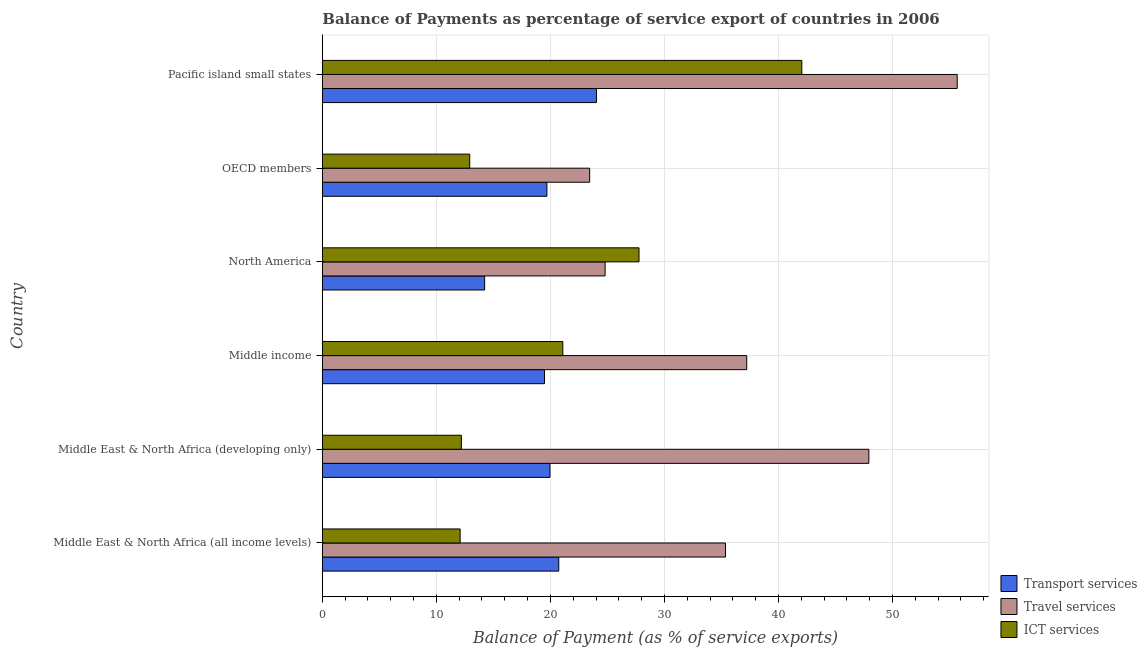How many different coloured bars are there?
Give a very brief answer. 3. How many groups of bars are there?
Offer a terse response. 6. Are the number of bars per tick equal to the number of legend labels?
Your answer should be very brief. Yes. Are the number of bars on each tick of the Y-axis equal?
Provide a short and direct response. Yes. What is the label of the 5th group of bars from the top?
Keep it short and to the point. Middle East & North Africa (developing only). In how many cases, is the number of bars for a given country not equal to the number of legend labels?
Your answer should be very brief. 0. What is the balance of payment of ict services in OECD members?
Your answer should be compact. 12.93. Across all countries, what is the maximum balance of payment of transport services?
Offer a very short reply. 24.04. Across all countries, what is the minimum balance of payment of travel services?
Your answer should be very brief. 23.44. In which country was the balance of payment of transport services maximum?
Offer a very short reply. Pacific island small states. In which country was the balance of payment of transport services minimum?
Your answer should be compact. North America. What is the total balance of payment of ict services in the graph?
Make the answer very short. 128.11. What is the difference between the balance of payment of travel services in Middle East & North Africa (developing only) and that in OECD members?
Your response must be concise. 24.48. What is the difference between the balance of payment of ict services in OECD members and the balance of payment of travel services in North America?
Provide a succinct answer. -11.87. What is the average balance of payment of transport services per country?
Ensure brevity in your answer.  19.69. What is the difference between the balance of payment of transport services and balance of payment of travel services in Middle East & North Africa (all income levels)?
Ensure brevity in your answer.  -14.62. What is the ratio of the balance of payment of transport services in Middle East & North Africa (all income levels) to that in Middle East & North Africa (developing only)?
Ensure brevity in your answer.  1.04. What is the difference between the highest and the second highest balance of payment of transport services?
Provide a short and direct response. 3.31. What is the difference between the highest and the lowest balance of payment of travel services?
Keep it short and to the point. 32.23. In how many countries, is the balance of payment of ict services greater than the average balance of payment of ict services taken over all countries?
Your response must be concise. 2. What does the 2nd bar from the top in Middle East & North Africa (all income levels) represents?
Keep it short and to the point. Travel services. What does the 1st bar from the bottom in Middle East & North Africa (all income levels) represents?
Provide a succinct answer. Transport services. Is it the case that in every country, the sum of the balance of payment of transport services and balance of payment of travel services is greater than the balance of payment of ict services?
Provide a short and direct response. Yes. How many bars are there?
Give a very brief answer. 18. Are all the bars in the graph horizontal?
Provide a succinct answer. Yes. How many countries are there in the graph?
Your answer should be very brief. 6. Are the values on the major ticks of X-axis written in scientific E-notation?
Make the answer very short. No. Does the graph contain any zero values?
Your answer should be very brief. No. Does the graph contain grids?
Ensure brevity in your answer.  Yes. What is the title of the graph?
Make the answer very short. Balance of Payments as percentage of service export of countries in 2006. Does "Renewable sources" appear as one of the legend labels in the graph?
Ensure brevity in your answer.  No. What is the label or title of the X-axis?
Your response must be concise. Balance of Payment (as % of service exports). What is the label or title of the Y-axis?
Ensure brevity in your answer.  Country. What is the Balance of Payment (as % of service exports) of Transport services in Middle East & North Africa (all income levels)?
Your answer should be compact. 20.73. What is the Balance of Payment (as % of service exports) of Travel services in Middle East & North Africa (all income levels)?
Your answer should be compact. 35.36. What is the Balance of Payment (as % of service exports) in ICT services in Middle East & North Africa (all income levels)?
Your answer should be very brief. 12.08. What is the Balance of Payment (as % of service exports) of Transport services in Middle East & North Africa (developing only)?
Offer a terse response. 19.96. What is the Balance of Payment (as % of service exports) in Travel services in Middle East & North Africa (developing only)?
Provide a succinct answer. 47.93. What is the Balance of Payment (as % of service exports) of ICT services in Middle East & North Africa (developing only)?
Keep it short and to the point. 12.19. What is the Balance of Payment (as % of service exports) of Transport services in Middle income?
Your answer should be compact. 19.48. What is the Balance of Payment (as % of service exports) of Travel services in Middle income?
Offer a very short reply. 37.21. What is the Balance of Payment (as % of service exports) of ICT services in Middle income?
Give a very brief answer. 21.09. What is the Balance of Payment (as % of service exports) of Transport services in North America?
Your answer should be very brief. 14.23. What is the Balance of Payment (as % of service exports) of Travel services in North America?
Provide a succinct answer. 24.8. What is the Balance of Payment (as % of service exports) in ICT services in North America?
Offer a terse response. 27.77. What is the Balance of Payment (as % of service exports) of Transport services in OECD members?
Offer a very short reply. 19.69. What is the Balance of Payment (as % of service exports) of Travel services in OECD members?
Keep it short and to the point. 23.44. What is the Balance of Payment (as % of service exports) of ICT services in OECD members?
Provide a succinct answer. 12.93. What is the Balance of Payment (as % of service exports) in Transport services in Pacific island small states?
Ensure brevity in your answer.  24.04. What is the Balance of Payment (as % of service exports) in Travel services in Pacific island small states?
Keep it short and to the point. 55.67. What is the Balance of Payment (as % of service exports) in ICT services in Pacific island small states?
Provide a succinct answer. 42.04. Across all countries, what is the maximum Balance of Payment (as % of service exports) in Transport services?
Keep it short and to the point. 24.04. Across all countries, what is the maximum Balance of Payment (as % of service exports) in Travel services?
Give a very brief answer. 55.67. Across all countries, what is the maximum Balance of Payment (as % of service exports) of ICT services?
Ensure brevity in your answer.  42.04. Across all countries, what is the minimum Balance of Payment (as % of service exports) of Transport services?
Your answer should be compact. 14.23. Across all countries, what is the minimum Balance of Payment (as % of service exports) in Travel services?
Make the answer very short. 23.44. Across all countries, what is the minimum Balance of Payment (as % of service exports) in ICT services?
Offer a very short reply. 12.08. What is the total Balance of Payment (as % of service exports) of Transport services in the graph?
Keep it short and to the point. 118.14. What is the total Balance of Payment (as % of service exports) of Travel services in the graph?
Offer a very short reply. 224.41. What is the total Balance of Payment (as % of service exports) of ICT services in the graph?
Offer a very short reply. 128.11. What is the difference between the Balance of Payment (as % of service exports) of Transport services in Middle East & North Africa (all income levels) and that in Middle East & North Africa (developing only)?
Provide a succinct answer. 0.77. What is the difference between the Balance of Payment (as % of service exports) of Travel services in Middle East & North Africa (all income levels) and that in Middle East & North Africa (developing only)?
Your answer should be very brief. -12.57. What is the difference between the Balance of Payment (as % of service exports) in ICT services in Middle East & North Africa (all income levels) and that in Middle East & North Africa (developing only)?
Provide a succinct answer. -0.11. What is the difference between the Balance of Payment (as % of service exports) in Transport services in Middle East & North Africa (all income levels) and that in Middle income?
Provide a succinct answer. 1.25. What is the difference between the Balance of Payment (as % of service exports) of Travel services in Middle East & North Africa (all income levels) and that in Middle income?
Keep it short and to the point. -1.86. What is the difference between the Balance of Payment (as % of service exports) of ICT services in Middle East & North Africa (all income levels) and that in Middle income?
Keep it short and to the point. -9. What is the difference between the Balance of Payment (as % of service exports) of Transport services in Middle East & North Africa (all income levels) and that in North America?
Provide a short and direct response. 6.5. What is the difference between the Balance of Payment (as % of service exports) of Travel services in Middle East & North Africa (all income levels) and that in North America?
Your response must be concise. 10.56. What is the difference between the Balance of Payment (as % of service exports) in ICT services in Middle East & North Africa (all income levels) and that in North America?
Your answer should be very brief. -15.69. What is the difference between the Balance of Payment (as % of service exports) of Transport services in Middle East & North Africa (all income levels) and that in OECD members?
Provide a short and direct response. 1.04. What is the difference between the Balance of Payment (as % of service exports) of Travel services in Middle East & North Africa (all income levels) and that in OECD members?
Keep it short and to the point. 11.92. What is the difference between the Balance of Payment (as % of service exports) in ICT services in Middle East & North Africa (all income levels) and that in OECD members?
Your response must be concise. -0.84. What is the difference between the Balance of Payment (as % of service exports) of Transport services in Middle East & North Africa (all income levels) and that in Pacific island small states?
Make the answer very short. -3.3. What is the difference between the Balance of Payment (as % of service exports) in Travel services in Middle East & North Africa (all income levels) and that in Pacific island small states?
Provide a short and direct response. -20.31. What is the difference between the Balance of Payment (as % of service exports) of ICT services in Middle East & North Africa (all income levels) and that in Pacific island small states?
Your answer should be very brief. -29.96. What is the difference between the Balance of Payment (as % of service exports) of Transport services in Middle East & North Africa (developing only) and that in Middle income?
Your answer should be compact. 0.48. What is the difference between the Balance of Payment (as % of service exports) of Travel services in Middle East & North Africa (developing only) and that in Middle income?
Your answer should be compact. 10.71. What is the difference between the Balance of Payment (as % of service exports) in ICT services in Middle East & North Africa (developing only) and that in Middle income?
Provide a succinct answer. -8.9. What is the difference between the Balance of Payment (as % of service exports) of Transport services in Middle East & North Africa (developing only) and that in North America?
Provide a short and direct response. 5.73. What is the difference between the Balance of Payment (as % of service exports) of Travel services in Middle East & North Africa (developing only) and that in North America?
Provide a succinct answer. 23.13. What is the difference between the Balance of Payment (as % of service exports) of ICT services in Middle East & North Africa (developing only) and that in North America?
Ensure brevity in your answer.  -15.58. What is the difference between the Balance of Payment (as % of service exports) of Transport services in Middle East & North Africa (developing only) and that in OECD members?
Provide a short and direct response. 0.27. What is the difference between the Balance of Payment (as % of service exports) in Travel services in Middle East & North Africa (developing only) and that in OECD members?
Offer a terse response. 24.48. What is the difference between the Balance of Payment (as % of service exports) of ICT services in Middle East & North Africa (developing only) and that in OECD members?
Offer a very short reply. -0.73. What is the difference between the Balance of Payment (as % of service exports) in Transport services in Middle East & North Africa (developing only) and that in Pacific island small states?
Provide a short and direct response. -4.08. What is the difference between the Balance of Payment (as % of service exports) in Travel services in Middle East & North Africa (developing only) and that in Pacific island small states?
Your answer should be very brief. -7.75. What is the difference between the Balance of Payment (as % of service exports) in ICT services in Middle East & North Africa (developing only) and that in Pacific island small states?
Keep it short and to the point. -29.85. What is the difference between the Balance of Payment (as % of service exports) of Transport services in Middle income and that in North America?
Your answer should be very brief. 5.25. What is the difference between the Balance of Payment (as % of service exports) of Travel services in Middle income and that in North America?
Provide a succinct answer. 12.42. What is the difference between the Balance of Payment (as % of service exports) in ICT services in Middle income and that in North America?
Your answer should be very brief. -6.68. What is the difference between the Balance of Payment (as % of service exports) in Transport services in Middle income and that in OECD members?
Provide a short and direct response. -0.21. What is the difference between the Balance of Payment (as % of service exports) in Travel services in Middle income and that in OECD members?
Offer a terse response. 13.77. What is the difference between the Balance of Payment (as % of service exports) in ICT services in Middle income and that in OECD members?
Offer a terse response. 8.16. What is the difference between the Balance of Payment (as % of service exports) of Transport services in Middle income and that in Pacific island small states?
Offer a terse response. -4.56. What is the difference between the Balance of Payment (as % of service exports) of Travel services in Middle income and that in Pacific island small states?
Offer a very short reply. -18.46. What is the difference between the Balance of Payment (as % of service exports) of ICT services in Middle income and that in Pacific island small states?
Your response must be concise. -20.96. What is the difference between the Balance of Payment (as % of service exports) in Transport services in North America and that in OECD members?
Your answer should be compact. -5.46. What is the difference between the Balance of Payment (as % of service exports) of Travel services in North America and that in OECD members?
Keep it short and to the point. 1.36. What is the difference between the Balance of Payment (as % of service exports) in ICT services in North America and that in OECD members?
Offer a very short reply. 14.84. What is the difference between the Balance of Payment (as % of service exports) in Transport services in North America and that in Pacific island small states?
Your answer should be compact. -9.8. What is the difference between the Balance of Payment (as % of service exports) of Travel services in North America and that in Pacific island small states?
Your response must be concise. -30.87. What is the difference between the Balance of Payment (as % of service exports) in ICT services in North America and that in Pacific island small states?
Provide a short and direct response. -14.27. What is the difference between the Balance of Payment (as % of service exports) in Transport services in OECD members and that in Pacific island small states?
Provide a short and direct response. -4.34. What is the difference between the Balance of Payment (as % of service exports) in Travel services in OECD members and that in Pacific island small states?
Your answer should be very brief. -32.23. What is the difference between the Balance of Payment (as % of service exports) of ICT services in OECD members and that in Pacific island small states?
Offer a terse response. -29.12. What is the difference between the Balance of Payment (as % of service exports) of Transport services in Middle East & North Africa (all income levels) and the Balance of Payment (as % of service exports) of Travel services in Middle East & North Africa (developing only)?
Provide a succinct answer. -27.19. What is the difference between the Balance of Payment (as % of service exports) of Transport services in Middle East & North Africa (all income levels) and the Balance of Payment (as % of service exports) of ICT services in Middle East & North Africa (developing only)?
Your response must be concise. 8.54. What is the difference between the Balance of Payment (as % of service exports) in Travel services in Middle East & North Africa (all income levels) and the Balance of Payment (as % of service exports) in ICT services in Middle East & North Africa (developing only)?
Ensure brevity in your answer.  23.16. What is the difference between the Balance of Payment (as % of service exports) in Transport services in Middle East & North Africa (all income levels) and the Balance of Payment (as % of service exports) in Travel services in Middle income?
Your answer should be compact. -16.48. What is the difference between the Balance of Payment (as % of service exports) in Transport services in Middle East & North Africa (all income levels) and the Balance of Payment (as % of service exports) in ICT services in Middle income?
Make the answer very short. -0.36. What is the difference between the Balance of Payment (as % of service exports) of Travel services in Middle East & North Africa (all income levels) and the Balance of Payment (as % of service exports) of ICT services in Middle income?
Your answer should be compact. 14.27. What is the difference between the Balance of Payment (as % of service exports) of Transport services in Middle East & North Africa (all income levels) and the Balance of Payment (as % of service exports) of Travel services in North America?
Provide a succinct answer. -4.06. What is the difference between the Balance of Payment (as % of service exports) in Transport services in Middle East & North Africa (all income levels) and the Balance of Payment (as % of service exports) in ICT services in North America?
Offer a very short reply. -7.04. What is the difference between the Balance of Payment (as % of service exports) of Travel services in Middle East & North Africa (all income levels) and the Balance of Payment (as % of service exports) of ICT services in North America?
Make the answer very short. 7.59. What is the difference between the Balance of Payment (as % of service exports) in Transport services in Middle East & North Africa (all income levels) and the Balance of Payment (as % of service exports) in Travel services in OECD members?
Your response must be concise. -2.71. What is the difference between the Balance of Payment (as % of service exports) of Transport services in Middle East & North Africa (all income levels) and the Balance of Payment (as % of service exports) of ICT services in OECD members?
Give a very brief answer. 7.81. What is the difference between the Balance of Payment (as % of service exports) in Travel services in Middle East & North Africa (all income levels) and the Balance of Payment (as % of service exports) in ICT services in OECD members?
Provide a succinct answer. 22.43. What is the difference between the Balance of Payment (as % of service exports) of Transport services in Middle East & North Africa (all income levels) and the Balance of Payment (as % of service exports) of Travel services in Pacific island small states?
Give a very brief answer. -34.94. What is the difference between the Balance of Payment (as % of service exports) in Transport services in Middle East & North Africa (all income levels) and the Balance of Payment (as % of service exports) in ICT services in Pacific island small states?
Ensure brevity in your answer.  -21.31. What is the difference between the Balance of Payment (as % of service exports) of Travel services in Middle East & North Africa (all income levels) and the Balance of Payment (as % of service exports) of ICT services in Pacific island small states?
Your answer should be compact. -6.69. What is the difference between the Balance of Payment (as % of service exports) of Transport services in Middle East & North Africa (developing only) and the Balance of Payment (as % of service exports) of Travel services in Middle income?
Ensure brevity in your answer.  -17.25. What is the difference between the Balance of Payment (as % of service exports) in Transport services in Middle East & North Africa (developing only) and the Balance of Payment (as % of service exports) in ICT services in Middle income?
Offer a terse response. -1.13. What is the difference between the Balance of Payment (as % of service exports) of Travel services in Middle East & North Africa (developing only) and the Balance of Payment (as % of service exports) of ICT services in Middle income?
Keep it short and to the point. 26.84. What is the difference between the Balance of Payment (as % of service exports) in Transport services in Middle East & North Africa (developing only) and the Balance of Payment (as % of service exports) in Travel services in North America?
Make the answer very short. -4.83. What is the difference between the Balance of Payment (as % of service exports) in Transport services in Middle East & North Africa (developing only) and the Balance of Payment (as % of service exports) in ICT services in North America?
Give a very brief answer. -7.81. What is the difference between the Balance of Payment (as % of service exports) of Travel services in Middle East & North Africa (developing only) and the Balance of Payment (as % of service exports) of ICT services in North America?
Keep it short and to the point. 20.16. What is the difference between the Balance of Payment (as % of service exports) of Transport services in Middle East & North Africa (developing only) and the Balance of Payment (as % of service exports) of Travel services in OECD members?
Provide a short and direct response. -3.48. What is the difference between the Balance of Payment (as % of service exports) of Transport services in Middle East & North Africa (developing only) and the Balance of Payment (as % of service exports) of ICT services in OECD members?
Ensure brevity in your answer.  7.04. What is the difference between the Balance of Payment (as % of service exports) of Travel services in Middle East & North Africa (developing only) and the Balance of Payment (as % of service exports) of ICT services in OECD members?
Your answer should be very brief. 35. What is the difference between the Balance of Payment (as % of service exports) of Transport services in Middle East & North Africa (developing only) and the Balance of Payment (as % of service exports) of Travel services in Pacific island small states?
Provide a succinct answer. -35.71. What is the difference between the Balance of Payment (as % of service exports) of Transport services in Middle East & North Africa (developing only) and the Balance of Payment (as % of service exports) of ICT services in Pacific island small states?
Ensure brevity in your answer.  -22.08. What is the difference between the Balance of Payment (as % of service exports) in Travel services in Middle East & North Africa (developing only) and the Balance of Payment (as % of service exports) in ICT services in Pacific island small states?
Offer a very short reply. 5.88. What is the difference between the Balance of Payment (as % of service exports) of Transport services in Middle income and the Balance of Payment (as % of service exports) of Travel services in North America?
Keep it short and to the point. -5.32. What is the difference between the Balance of Payment (as % of service exports) in Transport services in Middle income and the Balance of Payment (as % of service exports) in ICT services in North America?
Offer a terse response. -8.29. What is the difference between the Balance of Payment (as % of service exports) in Travel services in Middle income and the Balance of Payment (as % of service exports) in ICT services in North America?
Offer a terse response. 9.44. What is the difference between the Balance of Payment (as % of service exports) in Transport services in Middle income and the Balance of Payment (as % of service exports) in Travel services in OECD members?
Offer a terse response. -3.96. What is the difference between the Balance of Payment (as % of service exports) in Transport services in Middle income and the Balance of Payment (as % of service exports) in ICT services in OECD members?
Make the answer very short. 6.56. What is the difference between the Balance of Payment (as % of service exports) in Travel services in Middle income and the Balance of Payment (as % of service exports) in ICT services in OECD members?
Ensure brevity in your answer.  24.29. What is the difference between the Balance of Payment (as % of service exports) of Transport services in Middle income and the Balance of Payment (as % of service exports) of Travel services in Pacific island small states?
Provide a succinct answer. -36.19. What is the difference between the Balance of Payment (as % of service exports) in Transport services in Middle income and the Balance of Payment (as % of service exports) in ICT services in Pacific island small states?
Offer a very short reply. -22.56. What is the difference between the Balance of Payment (as % of service exports) in Travel services in Middle income and the Balance of Payment (as % of service exports) in ICT services in Pacific island small states?
Give a very brief answer. -4.83. What is the difference between the Balance of Payment (as % of service exports) of Transport services in North America and the Balance of Payment (as % of service exports) of Travel services in OECD members?
Offer a terse response. -9.21. What is the difference between the Balance of Payment (as % of service exports) of Transport services in North America and the Balance of Payment (as % of service exports) of ICT services in OECD members?
Provide a short and direct response. 1.31. What is the difference between the Balance of Payment (as % of service exports) of Travel services in North America and the Balance of Payment (as % of service exports) of ICT services in OECD members?
Your answer should be very brief. 11.87. What is the difference between the Balance of Payment (as % of service exports) of Transport services in North America and the Balance of Payment (as % of service exports) of Travel services in Pacific island small states?
Your answer should be compact. -41.44. What is the difference between the Balance of Payment (as % of service exports) in Transport services in North America and the Balance of Payment (as % of service exports) in ICT services in Pacific island small states?
Your answer should be compact. -27.81. What is the difference between the Balance of Payment (as % of service exports) in Travel services in North America and the Balance of Payment (as % of service exports) in ICT services in Pacific island small states?
Provide a succinct answer. -17.25. What is the difference between the Balance of Payment (as % of service exports) of Transport services in OECD members and the Balance of Payment (as % of service exports) of Travel services in Pacific island small states?
Offer a very short reply. -35.98. What is the difference between the Balance of Payment (as % of service exports) in Transport services in OECD members and the Balance of Payment (as % of service exports) in ICT services in Pacific island small states?
Provide a succinct answer. -22.35. What is the difference between the Balance of Payment (as % of service exports) in Travel services in OECD members and the Balance of Payment (as % of service exports) in ICT services in Pacific island small states?
Provide a short and direct response. -18.6. What is the average Balance of Payment (as % of service exports) of Transport services per country?
Give a very brief answer. 19.69. What is the average Balance of Payment (as % of service exports) in Travel services per country?
Offer a very short reply. 37.4. What is the average Balance of Payment (as % of service exports) in ICT services per country?
Provide a succinct answer. 21.35. What is the difference between the Balance of Payment (as % of service exports) of Transport services and Balance of Payment (as % of service exports) of Travel services in Middle East & North Africa (all income levels)?
Your answer should be compact. -14.62. What is the difference between the Balance of Payment (as % of service exports) in Transport services and Balance of Payment (as % of service exports) in ICT services in Middle East & North Africa (all income levels)?
Make the answer very short. 8.65. What is the difference between the Balance of Payment (as % of service exports) in Travel services and Balance of Payment (as % of service exports) in ICT services in Middle East & North Africa (all income levels)?
Offer a terse response. 23.27. What is the difference between the Balance of Payment (as % of service exports) of Transport services and Balance of Payment (as % of service exports) of Travel services in Middle East & North Africa (developing only)?
Ensure brevity in your answer.  -27.96. What is the difference between the Balance of Payment (as % of service exports) in Transport services and Balance of Payment (as % of service exports) in ICT services in Middle East & North Africa (developing only)?
Keep it short and to the point. 7.77. What is the difference between the Balance of Payment (as % of service exports) of Travel services and Balance of Payment (as % of service exports) of ICT services in Middle East & North Africa (developing only)?
Offer a very short reply. 35.73. What is the difference between the Balance of Payment (as % of service exports) of Transport services and Balance of Payment (as % of service exports) of Travel services in Middle income?
Keep it short and to the point. -17.73. What is the difference between the Balance of Payment (as % of service exports) of Transport services and Balance of Payment (as % of service exports) of ICT services in Middle income?
Give a very brief answer. -1.61. What is the difference between the Balance of Payment (as % of service exports) in Travel services and Balance of Payment (as % of service exports) in ICT services in Middle income?
Your answer should be very brief. 16.13. What is the difference between the Balance of Payment (as % of service exports) in Transport services and Balance of Payment (as % of service exports) in Travel services in North America?
Your answer should be compact. -10.56. What is the difference between the Balance of Payment (as % of service exports) of Transport services and Balance of Payment (as % of service exports) of ICT services in North America?
Your response must be concise. -13.54. What is the difference between the Balance of Payment (as % of service exports) in Travel services and Balance of Payment (as % of service exports) in ICT services in North America?
Your answer should be very brief. -2.97. What is the difference between the Balance of Payment (as % of service exports) in Transport services and Balance of Payment (as % of service exports) in Travel services in OECD members?
Offer a very short reply. -3.75. What is the difference between the Balance of Payment (as % of service exports) in Transport services and Balance of Payment (as % of service exports) in ICT services in OECD members?
Your answer should be compact. 6.77. What is the difference between the Balance of Payment (as % of service exports) in Travel services and Balance of Payment (as % of service exports) in ICT services in OECD members?
Make the answer very short. 10.51. What is the difference between the Balance of Payment (as % of service exports) in Transport services and Balance of Payment (as % of service exports) in Travel services in Pacific island small states?
Your answer should be very brief. -31.63. What is the difference between the Balance of Payment (as % of service exports) in Transport services and Balance of Payment (as % of service exports) in ICT services in Pacific island small states?
Your answer should be very brief. -18.01. What is the difference between the Balance of Payment (as % of service exports) in Travel services and Balance of Payment (as % of service exports) in ICT services in Pacific island small states?
Your answer should be very brief. 13.63. What is the ratio of the Balance of Payment (as % of service exports) in Transport services in Middle East & North Africa (all income levels) to that in Middle East & North Africa (developing only)?
Keep it short and to the point. 1.04. What is the ratio of the Balance of Payment (as % of service exports) of Travel services in Middle East & North Africa (all income levels) to that in Middle East & North Africa (developing only)?
Your answer should be very brief. 0.74. What is the ratio of the Balance of Payment (as % of service exports) in Transport services in Middle East & North Africa (all income levels) to that in Middle income?
Ensure brevity in your answer.  1.06. What is the ratio of the Balance of Payment (as % of service exports) of Travel services in Middle East & North Africa (all income levels) to that in Middle income?
Your response must be concise. 0.95. What is the ratio of the Balance of Payment (as % of service exports) in ICT services in Middle East & North Africa (all income levels) to that in Middle income?
Your answer should be very brief. 0.57. What is the ratio of the Balance of Payment (as % of service exports) in Transport services in Middle East & North Africa (all income levels) to that in North America?
Your answer should be very brief. 1.46. What is the ratio of the Balance of Payment (as % of service exports) of Travel services in Middle East & North Africa (all income levels) to that in North America?
Your answer should be very brief. 1.43. What is the ratio of the Balance of Payment (as % of service exports) of ICT services in Middle East & North Africa (all income levels) to that in North America?
Your answer should be very brief. 0.44. What is the ratio of the Balance of Payment (as % of service exports) in Transport services in Middle East & North Africa (all income levels) to that in OECD members?
Your answer should be compact. 1.05. What is the ratio of the Balance of Payment (as % of service exports) in Travel services in Middle East & North Africa (all income levels) to that in OECD members?
Your answer should be compact. 1.51. What is the ratio of the Balance of Payment (as % of service exports) in ICT services in Middle East & North Africa (all income levels) to that in OECD members?
Your answer should be compact. 0.93. What is the ratio of the Balance of Payment (as % of service exports) of Transport services in Middle East & North Africa (all income levels) to that in Pacific island small states?
Give a very brief answer. 0.86. What is the ratio of the Balance of Payment (as % of service exports) in Travel services in Middle East & North Africa (all income levels) to that in Pacific island small states?
Your answer should be very brief. 0.64. What is the ratio of the Balance of Payment (as % of service exports) of ICT services in Middle East & North Africa (all income levels) to that in Pacific island small states?
Ensure brevity in your answer.  0.29. What is the ratio of the Balance of Payment (as % of service exports) in Transport services in Middle East & North Africa (developing only) to that in Middle income?
Provide a succinct answer. 1.02. What is the ratio of the Balance of Payment (as % of service exports) in Travel services in Middle East & North Africa (developing only) to that in Middle income?
Provide a short and direct response. 1.29. What is the ratio of the Balance of Payment (as % of service exports) in ICT services in Middle East & North Africa (developing only) to that in Middle income?
Provide a succinct answer. 0.58. What is the ratio of the Balance of Payment (as % of service exports) of Transport services in Middle East & North Africa (developing only) to that in North America?
Your answer should be very brief. 1.4. What is the ratio of the Balance of Payment (as % of service exports) of Travel services in Middle East & North Africa (developing only) to that in North America?
Offer a very short reply. 1.93. What is the ratio of the Balance of Payment (as % of service exports) in ICT services in Middle East & North Africa (developing only) to that in North America?
Offer a very short reply. 0.44. What is the ratio of the Balance of Payment (as % of service exports) of Transport services in Middle East & North Africa (developing only) to that in OECD members?
Provide a succinct answer. 1.01. What is the ratio of the Balance of Payment (as % of service exports) in Travel services in Middle East & North Africa (developing only) to that in OECD members?
Offer a very short reply. 2.04. What is the ratio of the Balance of Payment (as % of service exports) of ICT services in Middle East & North Africa (developing only) to that in OECD members?
Your response must be concise. 0.94. What is the ratio of the Balance of Payment (as % of service exports) in Transport services in Middle East & North Africa (developing only) to that in Pacific island small states?
Provide a succinct answer. 0.83. What is the ratio of the Balance of Payment (as % of service exports) of Travel services in Middle East & North Africa (developing only) to that in Pacific island small states?
Offer a terse response. 0.86. What is the ratio of the Balance of Payment (as % of service exports) in ICT services in Middle East & North Africa (developing only) to that in Pacific island small states?
Ensure brevity in your answer.  0.29. What is the ratio of the Balance of Payment (as % of service exports) of Transport services in Middle income to that in North America?
Your response must be concise. 1.37. What is the ratio of the Balance of Payment (as % of service exports) in Travel services in Middle income to that in North America?
Give a very brief answer. 1.5. What is the ratio of the Balance of Payment (as % of service exports) in ICT services in Middle income to that in North America?
Keep it short and to the point. 0.76. What is the ratio of the Balance of Payment (as % of service exports) in Travel services in Middle income to that in OECD members?
Ensure brevity in your answer.  1.59. What is the ratio of the Balance of Payment (as % of service exports) in ICT services in Middle income to that in OECD members?
Keep it short and to the point. 1.63. What is the ratio of the Balance of Payment (as % of service exports) in Transport services in Middle income to that in Pacific island small states?
Offer a terse response. 0.81. What is the ratio of the Balance of Payment (as % of service exports) in Travel services in Middle income to that in Pacific island small states?
Keep it short and to the point. 0.67. What is the ratio of the Balance of Payment (as % of service exports) in ICT services in Middle income to that in Pacific island small states?
Ensure brevity in your answer.  0.5. What is the ratio of the Balance of Payment (as % of service exports) in Transport services in North America to that in OECD members?
Provide a short and direct response. 0.72. What is the ratio of the Balance of Payment (as % of service exports) of Travel services in North America to that in OECD members?
Your answer should be very brief. 1.06. What is the ratio of the Balance of Payment (as % of service exports) of ICT services in North America to that in OECD members?
Make the answer very short. 2.15. What is the ratio of the Balance of Payment (as % of service exports) of Transport services in North America to that in Pacific island small states?
Your answer should be compact. 0.59. What is the ratio of the Balance of Payment (as % of service exports) of Travel services in North America to that in Pacific island small states?
Make the answer very short. 0.45. What is the ratio of the Balance of Payment (as % of service exports) in ICT services in North America to that in Pacific island small states?
Ensure brevity in your answer.  0.66. What is the ratio of the Balance of Payment (as % of service exports) of Transport services in OECD members to that in Pacific island small states?
Provide a succinct answer. 0.82. What is the ratio of the Balance of Payment (as % of service exports) of Travel services in OECD members to that in Pacific island small states?
Your answer should be very brief. 0.42. What is the ratio of the Balance of Payment (as % of service exports) in ICT services in OECD members to that in Pacific island small states?
Ensure brevity in your answer.  0.31. What is the difference between the highest and the second highest Balance of Payment (as % of service exports) of Transport services?
Ensure brevity in your answer.  3.3. What is the difference between the highest and the second highest Balance of Payment (as % of service exports) in Travel services?
Provide a succinct answer. 7.75. What is the difference between the highest and the second highest Balance of Payment (as % of service exports) of ICT services?
Your response must be concise. 14.27. What is the difference between the highest and the lowest Balance of Payment (as % of service exports) in Transport services?
Your response must be concise. 9.8. What is the difference between the highest and the lowest Balance of Payment (as % of service exports) of Travel services?
Provide a short and direct response. 32.23. What is the difference between the highest and the lowest Balance of Payment (as % of service exports) of ICT services?
Keep it short and to the point. 29.96. 